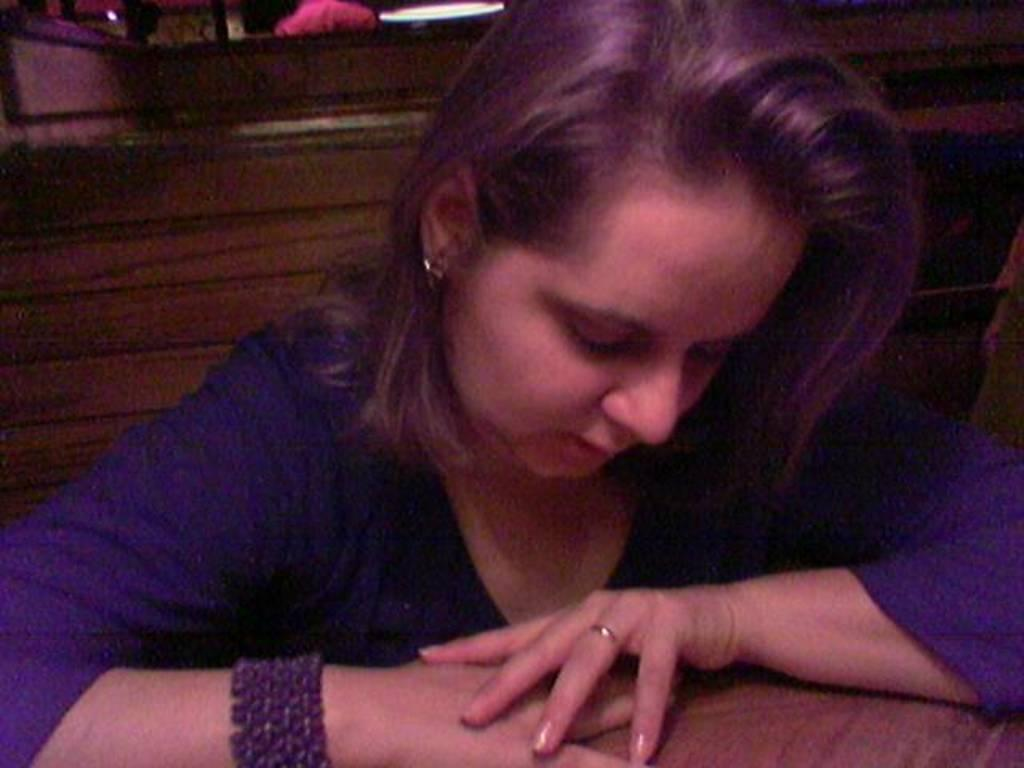What is the woman in the image doing? The woman is sitting in the image. Can you describe the other human in the image? There is another human in the image, but their actions or position are not specified. What can be seen in the background of the image? There is a light in the background of the image. What is located at the bottom of the image? There appears to be a table at the bottom of the image. What sense does the woman in the image use to interact with her sister? There is no mention of a sister in the image, and therefore we cannot determine which sense the woman might use to interact with her. 